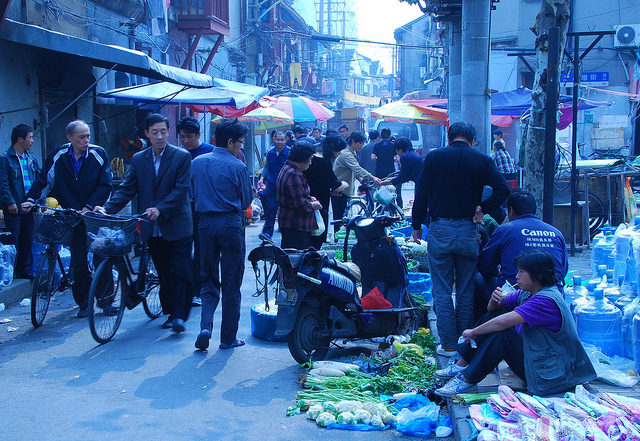Extract all visible text content from this image. Canon 